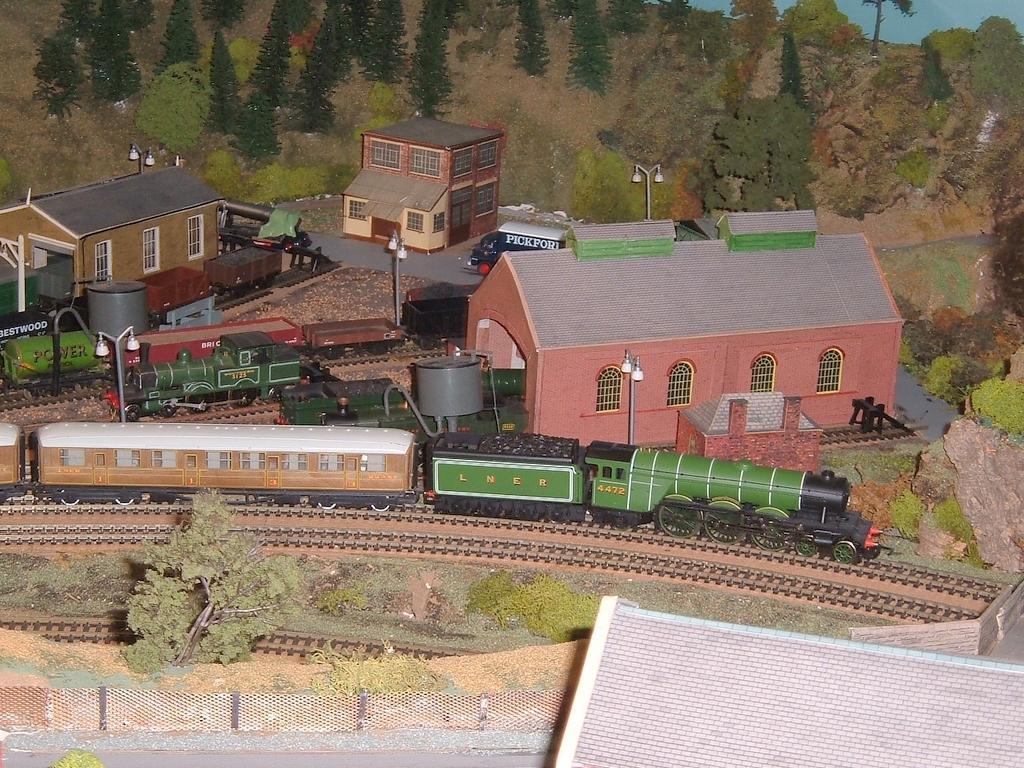Can you describe this image briefly? In this picture there are trains and houses in the center of the image and there are trees at the top side of the image, there is a boundary at the bottom side of the image. 